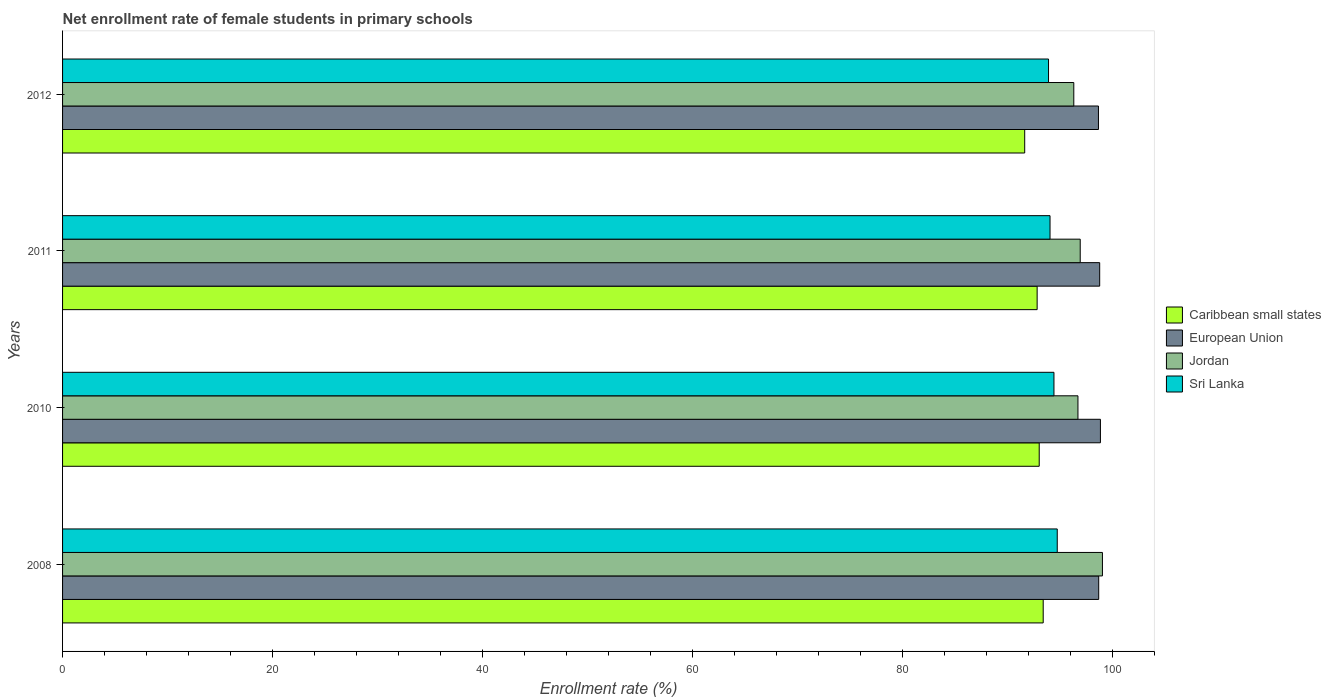Are the number of bars per tick equal to the number of legend labels?
Your response must be concise. Yes. Are the number of bars on each tick of the Y-axis equal?
Give a very brief answer. Yes. How many bars are there on the 1st tick from the top?
Ensure brevity in your answer.  4. What is the net enrollment rate of female students in primary schools in Caribbean small states in 2012?
Provide a short and direct response. 91.64. Across all years, what is the maximum net enrollment rate of female students in primary schools in European Union?
Give a very brief answer. 98.86. Across all years, what is the minimum net enrollment rate of female students in primary schools in Jordan?
Ensure brevity in your answer.  96.32. In which year was the net enrollment rate of female students in primary schools in Caribbean small states minimum?
Your response must be concise. 2012. What is the total net enrollment rate of female students in primary schools in Caribbean small states in the graph?
Give a very brief answer. 370.91. What is the difference between the net enrollment rate of female students in primary schools in Caribbean small states in 2010 and that in 2011?
Provide a short and direct response. 0.2. What is the difference between the net enrollment rate of female students in primary schools in Sri Lanka in 2010 and the net enrollment rate of female students in primary schools in Jordan in 2011?
Your answer should be compact. -2.5. What is the average net enrollment rate of female students in primary schools in Sri Lanka per year?
Provide a short and direct response. 94.29. In the year 2011, what is the difference between the net enrollment rate of female students in primary schools in Caribbean small states and net enrollment rate of female students in primary schools in European Union?
Keep it short and to the point. -5.96. In how many years, is the net enrollment rate of female students in primary schools in Caribbean small states greater than 88 %?
Ensure brevity in your answer.  4. What is the ratio of the net enrollment rate of female students in primary schools in Sri Lanka in 2010 to that in 2011?
Provide a short and direct response. 1. Is the net enrollment rate of female students in primary schools in Sri Lanka in 2010 less than that in 2011?
Give a very brief answer. No. Is the difference between the net enrollment rate of female students in primary schools in Caribbean small states in 2008 and 2010 greater than the difference between the net enrollment rate of female students in primary schools in European Union in 2008 and 2010?
Your answer should be very brief. Yes. What is the difference between the highest and the second highest net enrollment rate of female students in primary schools in Caribbean small states?
Keep it short and to the point. 0.38. What is the difference between the highest and the lowest net enrollment rate of female students in primary schools in Caribbean small states?
Provide a succinct answer. 1.76. In how many years, is the net enrollment rate of female students in primary schools in Caribbean small states greater than the average net enrollment rate of female students in primary schools in Caribbean small states taken over all years?
Give a very brief answer. 3. Is the sum of the net enrollment rate of female students in primary schools in European Union in 2011 and 2012 greater than the maximum net enrollment rate of female students in primary schools in Jordan across all years?
Keep it short and to the point. Yes. What does the 4th bar from the top in 2008 represents?
Ensure brevity in your answer.  Caribbean small states. What does the 4th bar from the bottom in 2011 represents?
Your response must be concise. Sri Lanka. Is it the case that in every year, the sum of the net enrollment rate of female students in primary schools in Caribbean small states and net enrollment rate of female students in primary schools in Jordan is greater than the net enrollment rate of female students in primary schools in European Union?
Offer a terse response. Yes. How many bars are there?
Give a very brief answer. 16. Are all the bars in the graph horizontal?
Your answer should be very brief. Yes. What is the difference between two consecutive major ticks on the X-axis?
Offer a very short reply. 20. Are the values on the major ticks of X-axis written in scientific E-notation?
Your answer should be compact. No. Does the graph contain any zero values?
Give a very brief answer. No. Does the graph contain grids?
Offer a very short reply. No. What is the title of the graph?
Offer a terse response. Net enrollment rate of female students in primary schools. What is the label or title of the X-axis?
Offer a terse response. Enrollment rate (%). What is the Enrollment rate (%) in Caribbean small states in 2008?
Provide a succinct answer. 93.41. What is the Enrollment rate (%) in European Union in 2008?
Provide a short and direct response. 98.69. What is the Enrollment rate (%) in Jordan in 2008?
Make the answer very short. 99.05. What is the Enrollment rate (%) in Sri Lanka in 2008?
Keep it short and to the point. 94.74. What is the Enrollment rate (%) of Caribbean small states in 2010?
Your answer should be very brief. 93.03. What is the Enrollment rate (%) in European Union in 2010?
Your answer should be compact. 98.86. What is the Enrollment rate (%) of Jordan in 2010?
Offer a very short reply. 96.72. What is the Enrollment rate (%) of Sri Lanka in 2010?
Keep it short and to the point. 94.43. What is the Enrollment rate (%) of Caribbean small states in 2011?
Your answer should be very brief. 92.83. What is the Enrollment rate (%) in European Union in 2011?
Your answer should be compact. 98.79. What is the Enrollment rate (%) of Jordan in 2011?
Your answer should be very brief. 96.93. What is the Enrollment rate (%) of Sri Lanka in 2011?
Ensure brevity in your answer.  94.06. What is the Enrollment rate (%) of Caribbean small states in 2012?
Ensure brevity in your answer.  91.64. What is the Enrollment rate (%) of European Union in 2012?
Your answer should be very brief. 98.67. What is the Enrollment rate (%) of Jordan in 2012?
Your response must be concise. 96.32. What is the Enrollment rate (%) of Sri Lanka in 2012?
Make the answer very short. 93.92. Across all years, what is the maximum Enrollment rate (%) of Caribbean small states?
Provide a short and direct response. 93.41. Across all years, what is the maximum Enrollment rate (%) in European Union?
Provide a succinct answer. 98.86. Across all years, what is the maximum Enrollment rate (%) in Jordan?
Offer a terse response. 99.05. Across all years, what is the maximum Enrollment rate (%) of Sri Lanka?
Keep it short and to the point. 94.74. Across all years, what is the minimum Enrollment rate (%) in Caribbean small states?
Offer a terse response. 91.64. Across all years, what is the minimum Enrollment rate (%) of European Union?
Offer a terse response. 98.67. Across all years, what is the minimum Enrollment rate (%) of Jordan?
Give a very brief answer. 96.32. Across all years, what is the minimum Enrollment rate (%) in Sri Lanka?
Offer a very short reply. 93.92. What is the total Enrollment rate (%) of Caribbean small states in the graph?
Offer a very short reply. 370.91. What is the total Enrollment rate (%) of European Union in the graph?
Provide a succinct answer. 395.01. What is the total Enrollment rate (%) in Jordan in the graph?
Your response must be concise. 389.02. What is the total Enrollment rate (%) of Sri Lanka in the graph?
Offer a terse response. 377.15. What is the difference between the Enrollment rate (%) of Caribbean small states in 2008 and that in 2010?
Make the answer very short. 0.38. What is the difference between the Enrollment rate (%) of European Union in 2008 and that in 2010?
Make the answer very short. -0.16. What is the difference between the Enrollment rate (%) in Jordan in 2008 and that in 2010?
Give a very brief answer. 2.33. What is the difference between the Enrollment rate (%) of Sri Lanka in 2008 and that in 2010?
Your answer should be very brief. 0.31. What is the difference between the Enrollment rate (%) of Caribbean small states in 2008 and that in 2011?
Keep it short and to the point. 0.58. What is the difference between the Enrollment rate (%) of European Union in 2008 and that in 2011?
Keep it short and to the point. -0.09. What is the difference between the Enrollment rate (%) in Jordan in 2008 and that in 2011?
Your response must be concise. 2.12. What is the difference between the Enrollment rate (%) in Sri Lanka in 2008 and that in 2011?
Your response must be concise. 0.69. What is the difference between the Enrollment rate (%) in Caribbean small states in 2008 and that in 2012?
Your response must be concise. 1.76. What is the difference between the Enrollment rate (%) of European Union in 2008 and that in 2012?
Ensure brevity in your answer.  0.02. What is the difference between the Enrollment rate (%) of Jordan in 2008 and that in 2012?
Give a very brief answer. 2.73. What is the difference between the Enrollment rate (%) in Sri Lanka in 2008 and that in 2012?
Offer a very short reply. 0.83. What is the difference between the Enrollment rate (%) in Caribbean small states in 2010 and that in 2011?
Your response must be concise. 0.2. What is the difference between the Enrollment rate (%) of European Union in 2010 and that in 2011?
Your answer should be compact. 0.07. What is the difference between the Enrollment rate (%) of Jordan in 2010 and that in 2011?
Make the answer very short. -0.22. What is the difference between the Enrollment rate (%) of Sri Lanka in 2010 and that in 2011?
Provide a short and direct response. 0.37. What is the difference between the Enrollment rate (%) in Caribbean small states in 2010 and that in 2012?
Offer a terse response. 1.38. What is the difference between the Enrollment rate (%) of European Union in 2010 and that in 2012?
Provide a short and direct response. 0.19. What is the difference between the Enrollment rate (%) of Jordan in 2010 and that in 2012?
Your response must be concise. 0.4. What is the difference between the Enrollment rate (%) of Sri Lanka in 2010 and that in 2012?
Make the answer very short. 0.52. What is the difference between the Enrollment rate (%) in Caribbean small states in 2011 and that in 2012?
Give a very brief answer. 1.19. What is the difference between the Enrollment rate (%) of European Union in 2011 and that in 2012?
Provide a short and direct response. 0.12. What is the difference between the Enrollment rate (%) of Jordan in 2011 and that in 2012?
Provide a succinct answer. 0.61. What is the difference between the Enrollment rate (%) of Sri Lanka in 2011 and that in 2012?
Give a very brief answer. 0.14. What is the difference between the Enrollment rate (%) in Caribbean small states in 2008 and the Enrollment rate (%) in European Union in 2010?
Provide a succinct answer. -5.45. What is the difference between the Enrollment rate (%) in Caribbean small states in 2008 and the Enrollment rate (%) in Jordan in 2010?
Offer a very short reply. -3.31. What is the difference between the Enrollment rate (%) of Caribbean small states in 2008 and the Enrollment rate (%) of Sri Lanka in 2010?
Ensure brevity in your answer.  -1.02. What is the difference between the Enrollment rate (%) in European Union in 2008 and the Enrollment rate (%) in Jordan in 2010?
Your response must be concise. 1.98. What is the difference between the Enrollment rate (%) of European Union in 2008 and the Enrollment rate (%) of Sri Lanka in 2010?
Ensure brevity in your answer.  4.26. What is the difference between the Enrollment rate (%) of Jordan in 2008 and the Enrollment rate (%) of Sri Lanka in 2010?
Offer a very short reply. 4.62. What is the difference between the Enrollment rate (%) of Caribbean small states in 2008 and the Enrollment rate (%) of European Union in 2011?
Provide a succinct answer. -5.38. What is the difference between the Enrollment rate (%) of Caribbean small states in 2008 and the Enrollment rate (%) of Jordan in 2011?
Provide a succinct answer. -3.53. What is the difference between the Enrollment rate (%) of Caribbean small states in 2008 and the Enrollment rate (%) of Sri Lanka in 2011?
Offer a very short reply. -0.65. What is the difference between the Enrollment rate (%) of European Union in 2008 and the Enrollment rate (%) of Jordan in 2011?
Ensure brevity in your answer.  1.76. What is the difference between the Enrollment rate (%) in European Union in 2008 and the Enrollment rate (%) in Sri Lanka in 2011?
Ensure brevity in your answer.  4.64. What is the difference between the Enrollment rate (%) of Jordan in 2008 and the Enrollment rate (%) of Sri Lanka in 2011?
Provide a short and direct response. 4.99. What is the difference between the Enrollment rate (%) of Caribbean small states in 2008 and the Enrollment rate (%) of European Union in 2012?
Your answer should be compact. -5.26. What is the difference between the Enrollment rate (%) in Caribbean small states in 2008 and the Enrollment rate (%) in Jordan in 2012?
Keep it short and to the point. -2.91. What is the difference between the Enrollment rate (%) of Caribbean small states in 2008 and the Enrollment rate (%) of Sri Lanka in 2012?
Provide a short and direct response. -0.51. What is the difference between the Enrollment rate (%) of European Union in 2008 and the Enrollment rate (%) of Jordan in 2012?
Provide a short and direct response. 2.37. What is the difference between the Enrollment rate (%) in European Union in 2008 and the Enrollment rate (%) in Sri Lanka in 2012?
Provide a succinct answer. 4.78. What is the difference between the Enrollment rate (%) in Jordan in 2008 and the Enrollment rate (%) in Sri Lanka in 2012?
Your answer should be very brief. 5.13. What is the difference between the Enrollment rate (%) of Caribbean small states in 2010 and the Enrollment rate (%) of European Union in 2011?
Your response must be concise. -5.76. What is the difference between the Enrollment rate (%) in Caribbean small states in 2010 and the Enrollment rate (%) in Jordan in 2011?
Offer a very short reply. -3.91. What is the difference between the Enrollment rate (%) of Caribbean small states in 2010 and the Enrollment rate (%) of Sri Lanka in 2011?
Give a very brief answer. -1.03. What is the difference between the Enrollment rate (%) of European Union in 2010 and the Enrollment rate (%) of Jordan in 2011?
Provide a short and direct response. 1.93. What is the difference between the Enrollment rate (%) of European Union in 2010 and the Enrollment rate (%) of Sri Lanka in 2011?
Keep it short and to the point. 4.8. What is the difference between the Enrollment rate (%) of Jordan in 2010 and the Enrollment rate (%) of Sri Lanka in 2011?
Your response must be concise. 2.66. What is the difference between the Enrollment rate (%) in Caribbean small states in 2010 and the Enrollment rate (%) in European Union in 2012?
Your answer should be compact. -5.64. What is the difference between the Enrollment rate (%) in Caribbean small states in 2010 and the Enrollment rate (%) in Jordan in 2012?
Ensure brevity in your answer.  -3.29. What is the difference between the Enrollment rate (%) of Caribbean small states in 2010 and the Enrollment rate (%) of Sri Lanka in 2012?
Make the answer very short. -0.89. What is the difference between the Enrollment rate (%) in European Union in 2010 and the Enrollment rate (%) in Jordan in 2012?
Give a very brief answer. 2.54. What is the difference between the Enrollment rate (%) of European Union in 2010 and the Enrollment rate (%) of Sri Lanka in 2012?
Ensure brevity in your answer.  4.94. What is the difference between the Enrollment rate (%) of Jordan in 2010 and the Enrollment rate (%) of Sri Lanka in 2012?
Offer a very short reply. 2.8. What is the difference between the Enrollment rate (%) of Caribbean small states in 2011 and the Enrollment rate (%) of European Union in 2012?
Your response must be concise. -5.84. What is the difference between the Enrollment rate (%) in Caribbean small states in 2011 and the Enrollment rate (%) in Jordan in 2012?
Your answer should be very brief. -3.49. What is the difference between the Enrollment rate (%) in Caribbean small states in 2011 and the Enrollment rate (%) in Sri Lanka in 2012?
Your answer should be very brief. -1.09. What is the difference between the Enrollment rate (%) in European Union in 2011 and the Enrollment rate (%) in Jordan in 2012?
Your answer should be very brief. 2.47. What is the difference between the Enrollment rate (%) of European Union in 2011 and the Enrollment rate (%) of Sri Lanka in 2012?
Provide a succinct answer. 4.87. What is the difference between the Enrollment rate (%) in Jordan in 2011 and the Enrollment rate (%) in Sri Lanka in 2012?
Your answer should be compact. 3.02. What is the average Enrollment rate (%) in Caribbean small states per year?
Provide a short and direct response. 92.73. What is the average Enrollment rate (%) of European Union per year?
Offer a very short reply. 98.75. What is the average Enrollment rate (%) of Jordan per year?
Your answer should be very brief. 97.25. What is the average Enrollment rate (%) of Sri Lanka per year?
Offer a terse response. 94.29. In the year 2008, what is the difference between the Enrollment rate (%) of Caribbean small states and Enrollment rate (%) of European Union?
Your answer should be very brief. -5.29. In the year 2008, what is the difference between the Enrollment rate (%) of Caribbean small states and Enrollment rate (%) of Jordan?
Make the answer very short. -5.64. In the year 2008, what is the difference between the Enrollment rate (%) of Caribbean small states and Enrollment rate (%) of Sri Lanka?
Your answer should be compact. -1.34. In the year 2008, what is the difference between the Enrollment rate (%) of European Union and Enrollment rate (%) of Jordan?
Offer a very short reply. -0.36. In the year 2008, what is the difference between the Enrollment rate (%) of European Union and Enrollment rate (%) of Sri Lanka?
Your response must be concise. 3.95. In the year 2008, what is the difference between the Enrollment rate (%) in Jordan and Enrollment rate (%) in Sri Lanka?
Make the answer very short. 4.3. In the year 2010, what is the difference between the Enrollment rate (%) of Caribbean small states and Enrollment rate (%) of European Union?
Your answer should be compact. -5.83. In the year 2010, what is the difference between the Enrollment rate (%) of Caribbean small states and Enrollment rate (%) of Jordan?
Keep it short and to the point. -3.69. In the year 2010, what is the difference between the Enrollment rate (%) of Caribbean small states and Enrollment rate (%) of Sri Lanka?
Give a very brief answer. -1.4. In the year 2010, what is the difference between the Enrollment rate (%) of European Union and Enrollment rate (%) of Jordan?
Offer a terse response. 2.14. In the year 2010, what is the difference between the Enrollment rate (%) in European Union and Enrollment rate (%) in Sri Lanka?
Ensure brevity in your answer.  4.43. In the year 2010, what is the difference between the Enrollment rate (%) in Jordan and Enrollment rate (%) in Sri Lanka?
Ensure brevity in your answer.  2.29. In the year 2011, what is the difference between the Enrollment rate (%) of Caribbean small states and Enrollment rate (%) of European Union?
Offer a terse response. -5.96. In the year 2011, what is the difference between the Enrollment rate (%) of Caribbean small states and Enrollment rate (%) of Jordan?
Your answer should be very brief. -4.1. In the year 2011, what is the difference between the Enrollment rate (%) in Caribbean small states and Enrollment rate (%) in Sri Lanka?
Your response must be concise. -1.23. In the year 2011, what is the difference between the Enrollment rate (%) of European Union and Enrollment rate (%) of Jordan?
Your response must be concise. 1.85. In the year 2011, what is the difference between the Enrollment rate (%) in European Union and Enrollment rate (%) in Sri Lanka?
Your response must be concise. 4.73. In the year 2011, what is the difference between the Enrollment rate (%) in Jordan and Enrollment rate (%) in Sri Lanka?
Ensure brevity in your answer.  2.87. In the year 2012, what is the difference between the Enrollment rate (%) in Caribbean small states and Enrollment rate (%) in European Union?
Ensure brevity in your answer.  -7.03. In the year 2012, what is the difference between the Enrollment rate (%) in Caribbean small states and Enrollment rate (%) in Jordan?
Offer a terse response. -4.68. In the year 2012, what is the difference between the Enrollment rate (%) in Caribbean small states and Enrollment rate (%) in Sri Lanka?
Give a very brief answer. -2.27. In the year 2012, what is the difference between the Enrollment rate (%) in European Union and Enrollment rate (%) in Jordan?
Your answer should be very brief. 2.35. In the year 2012, what is the difference between the Enrollment rate (%) of European Union and Enrollment rate (%) of Sri Lanka?
Offer a terse response. 4.75. In the year 2012, what is the difference between the Enrollment rate (%) of Jordan and Enrollment rate (%) of Sri Lanka?
Your answer should be very brief. 2.41. What is the ratio of the Enrollment rate (%) in European Union in 2008 to that in 2010?
Give a very brief answer. 1. What is the ratio of the Enrollment rate (%) in Jordan in 2008 to that in 2010?
Provide a succinct answer. 1.02. What is the ratio of the Enrollment rate (%) of European Union in 2008 to that in 2011?
Your response must be concise. 1. What is the ratio of the Enrollment rate (%) of Jordan in 2008 to that in 2011?
Offer a terse response. 1.02. What is the ratio of the Enrollment rate (%) in Sri Lanka in 2008 to that in 2011?
Give a very brief answer. 1.01. What is the ratio of the Enrollment rate (%) of Caribbean small states in 2008 to that in 2012?
Your response must be concise. 1.02. What is the ratio of the Enrollment rate (%) in European Union in 2008 to that in 2012?
Keep it short and to the point. 1. What is the ratio of the Enrollment rate (%) in Jordan in 2008 to that in 2012?
Offer a terse response. 1.03. What is the ratio of the Enrollment rate (%) of Sri Lanka in 2008 to that in 2012?
Offer a very short reply. 1.01. What is the ratio of the Enrollment rate (%) in Caribbean small states in 2010 to that in 2012?
Make the answer very short. 1.02. What is the ratio of the Enrollment rate (%) of European Union in 2010 to that in 2012?
Your answer should be very brief. 1. What is the ratio of the Enrollment rate (%) of Jordan in 2010 to that in 2012?
Ensure brevity in your answer.  1. What is the ratio of the Enrollment rate (%) of Caribbean small states in 2011 to that in 2012?
Provide a succinct answer. 1.01. What is the ratio of the Enrollment rate (%) in European Union in 2011 to that in 2012?
Your answer should be compact. 1. What is the ratio of the Enrollment rate (%) in Sri Lanka in 2011 to that in 2012?
Ensure brevity in your answer.  1. What is the difference between the highest and the second highest Enrollment rate (%) in Caribbean small states?
Provide a succinct answer. 0.38. What is the difference between the highest and the second highest Enrollment rate (%) in European Union?
Your answer should be very brief. 0.07. What is the difference between the highest and the second highest Enrollment rate (%) of Jordan?
Provide a short and direct response. 2.12. What is the difference between the highest and the second highest Enrollment rate (%) of Sri Lanka?
Offer a very short reply. 0.31. What is the difference between the highest and the lowest Enrollment rate (%) of Caribbean small states?
Give a very brief answer. 1.76. What is the difference between the highest and the lowest Enrollment rate (%) in European Union?
Provide a succinct answer. 0.19. What is the difference between the highest and the lowest Enrollment rate (%) in Jordan?
Your response must be concise. 2.73. What is the difference between the highest and the lowest Enrollment rate (%) of Sri Lanka?
Offer a terse response. 0.83. 